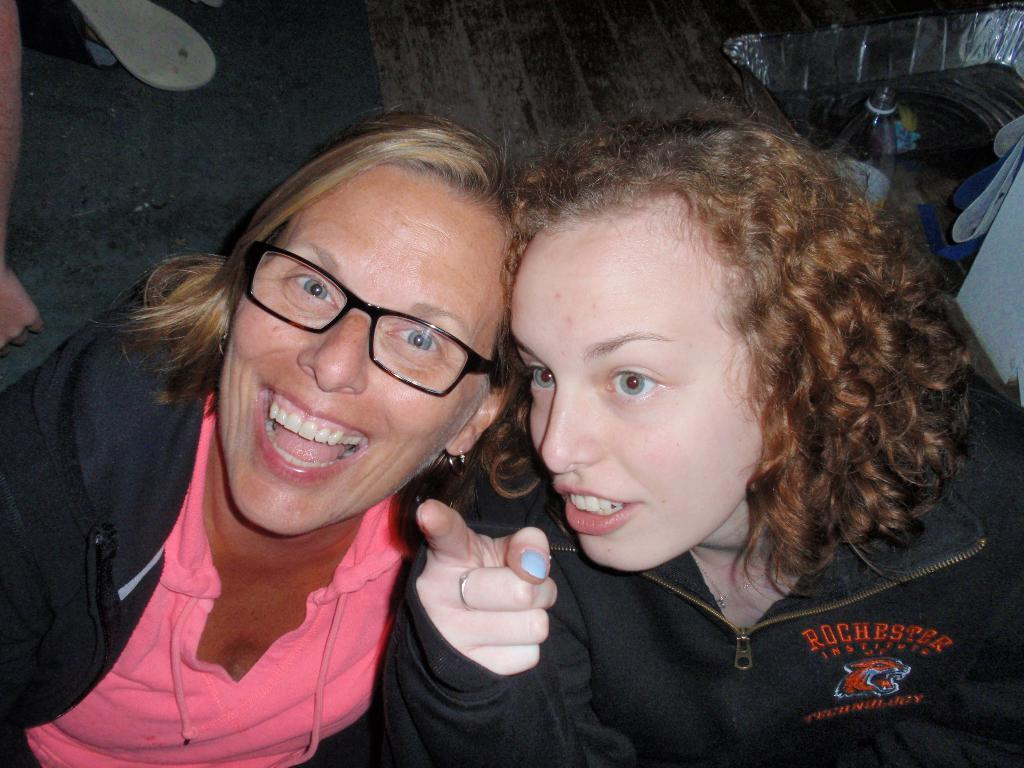How many women are in the image? There are two women in the image. Can you describe one of the women's appearance? One of the women is wearing spectacles. What can be seen in the background of the image? There is a bottle, footwear, and other unspecified objects in the background of the image. What type of protest is taking place in the image? There is no protest present in the image; it features two women and objects in the background. Can you describe the surgical procedure being performed on the woman in the image? There is no operation or surgical procedure being performed in the image; it features two women and objects in the background. 